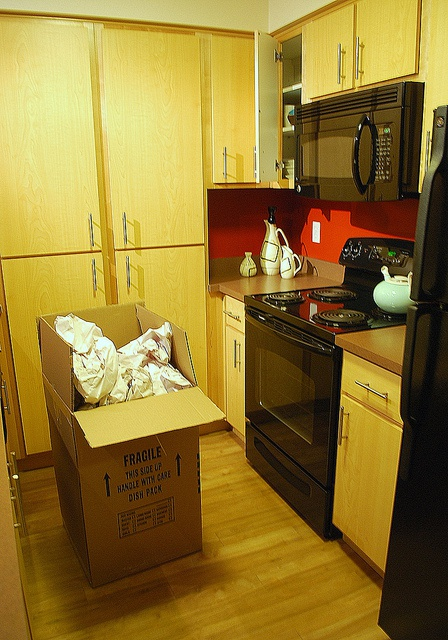Describe the objects in this image and their specific colors. I can see oven in khaki, black, maroon, and olive tones, refrigerator in khaki, black, olive, and gray tones, microwave in khaki, black, olive, and maroon tones, bottle in khaki, beige, tan, and black tones, and vase in khaki, beige, tan, and black tones in this image. 